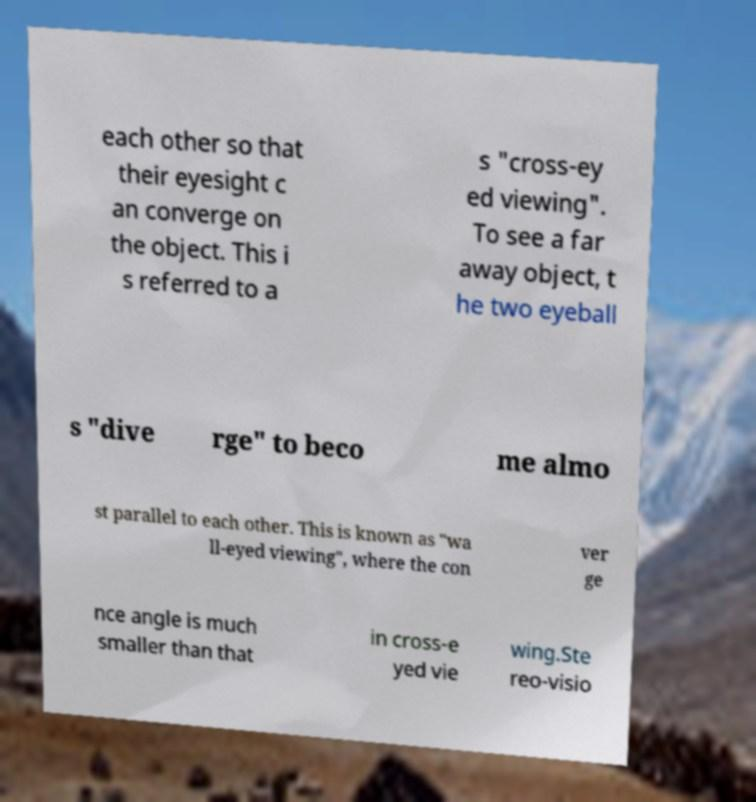Could you extract and type out the text from this image? each other so that their eyesight c an converge on the object. This i s referred to a s "cross-ey ed viewing". To see a far away object, t he two eyeball s "dive rge" to beco me almo st parallel to each other. This is known as "wa ll-eyed viewing", where the con ver ge nce angle is much smaller than that in cross-e yed vie wing.Ste reo-visio 